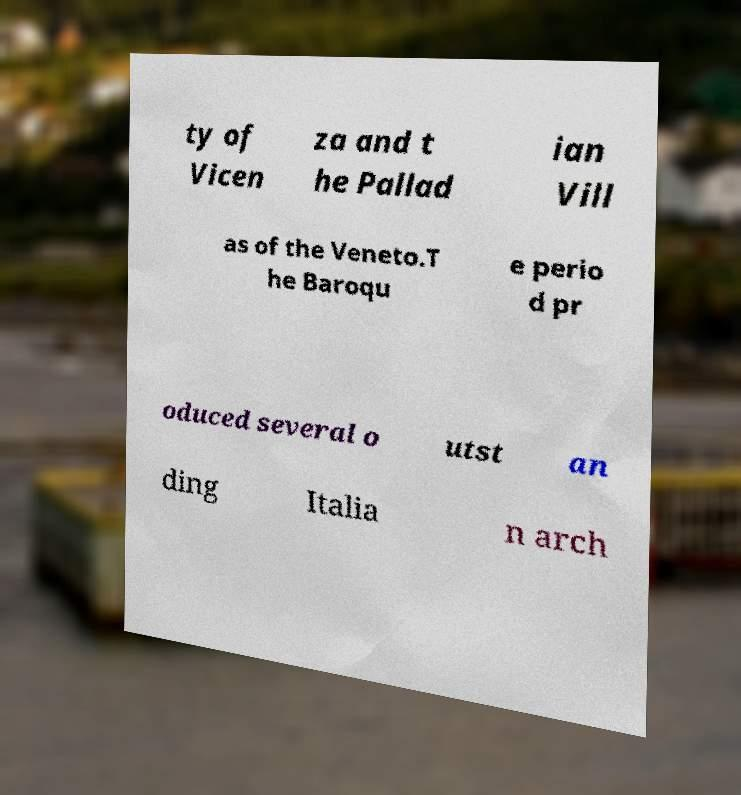Can you accurately transcribe the text from the provided image for me? ty of Vicen za and t he Pallad ian Vill as of the Veneto.T he Baroqu e perio d pr oduced several o utst an ding Italia n arch 